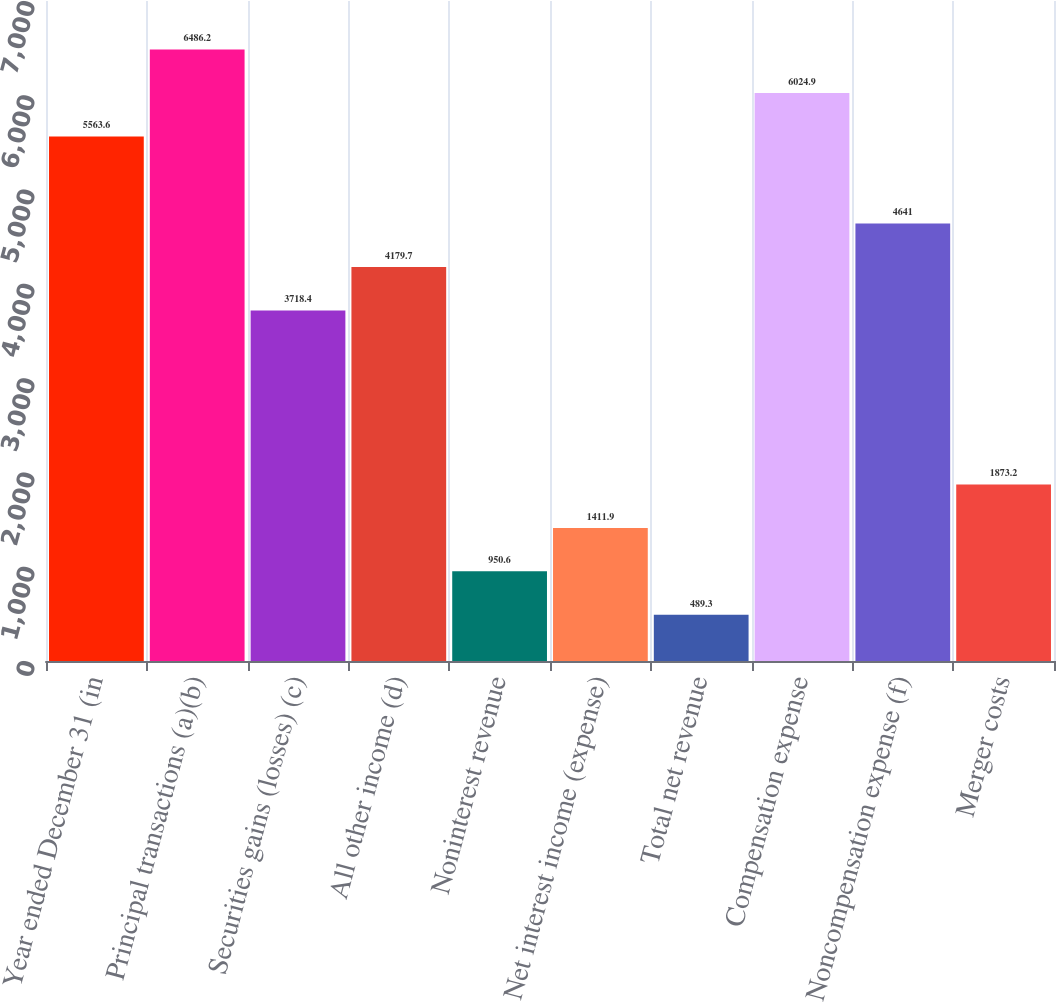Convert chart to OTSL. <chart><loc_0><loc_0><loc_500><loc_500><bar_chart><fcel>Year ended December 31 (in<fcel>Principal transactions (a)(b)<fcel>Securities gains (losses) (c)<fcel>All other income (d)<fcel>Noninterest revenue<fcel>Net interest income (expense)<fcel>Total net revenue<fcel>Compensation expense<fcel>Noncompensation expense (f)<fcel>Merger costs<nl><fcel>5563.6<fcel>6486.2<fcel>3718.4<fcel>4179.7<fcel>950.6<fcel>1411.9<fcel>489.3<fcel>6024.9<fcel>4641<fcel>1873.2<nl></chart> 